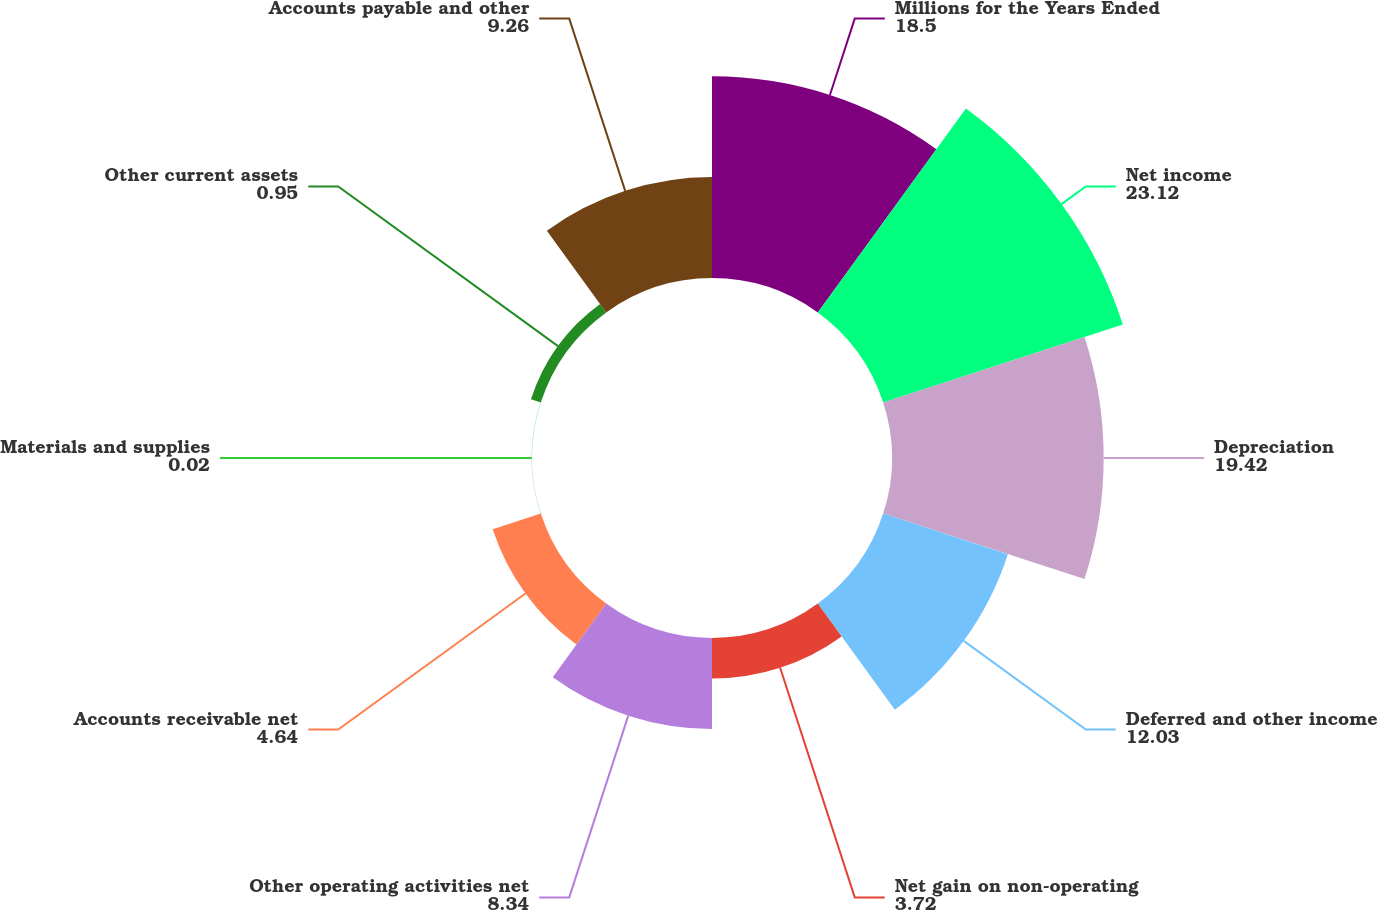<chart> <loc_0><loc_0><loc_500><loc_500><pie_chart><fcel>Millions for the Years Ended<fcel>Net income<fcel>Depreciation<fcel>Deferred and other income<fcel>Net gain on non-operating<fcel>Other operating activities net<fcel>Accounts receivable net<fcel>Materials and supplies<fcel>Other current assets<fcel>Accounts payable and other<nl><fcel>18.5%<fcel>23.12%<fcel>19.42%<fcel>12.03%<fcel>3.72%<fcel>8.34%<fcel>4.64%<fcel>0.02%<fcel>0.95%<fcel>9.26%<nl></chart> 